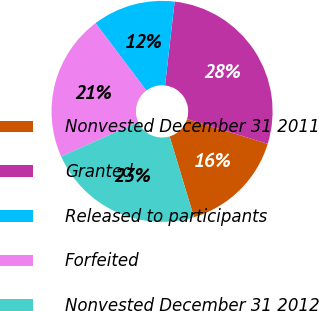<chart> <loc_0><loc_0><loc_500><loc_500><pie_chart><fcel>Nonvested December 31 2011<fcel>Granted<fcel>Released to participants<fcel>Forfeited<fcel>Nonvested December 31 2012<nl><fcel>15.6%<fcel>27.92%<fcel>12.09%<fcel>21.4%<fcel>22.98%<nl></chart> 